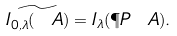<formula> <loc_0><loc_0><loc_500><loc_500>\widetilde { I _ { 0 , \lambda } ( \ A ) } = I _ { \lambda } ( \P P \ A ) .</formula> 